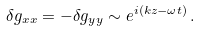<formula> <loc_0><loc_0><loc_500><loc_500>\delta g _ { x x } = - \delta g _ { y y } \sim e ^ { i ( k z - \omega t ) } \, .</formula> 